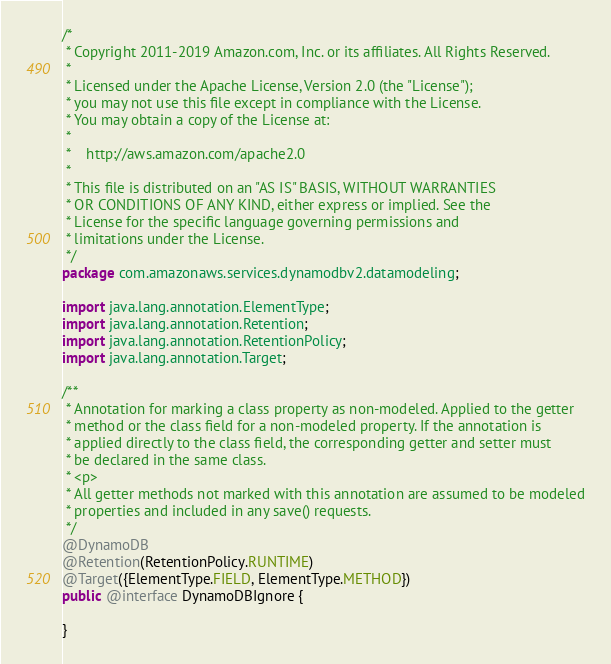<code> <loc_0><loc_0><loc_500><loc_500><_Java_>/*
 * Copyright 2011-2019 Amazon.com, Inc. or its affiliates. All Rights Reserved.
 *
 * Licensed under the Apache License, Version 2.0 (the "License");
 * you may not use this file except in compliance with the License.
 * You may obtain a copy of the License at:
 *
 *    http://aws.amazon.com/apache2.0
 *
 * This file is distributed on an "AS IS" BASIS, WITHOUT WARRANTIES
 * OR CONDITIONS OF ANY KIND, either express or implied. See the
 * License for the specific language governing permissions and
 * limitations under the License.
 */
package com.amazonaws.services.dynamodbv2.datamodeling;

import java.lang.annotation.ElementType;
import java.lang.annotation.Retention;
import java.lang.annotation.RetentionPolicy;
import java.lang.annotation.Target;

/**
 * Annotation for marking a class property as non-modeled. Applied to the getter
 * method or the class field for a non-modeled property. If the annotation is
 * applied directly to the class field, the corresponding getter and setter must
 * be declared in the same class.
 * <p>
 * All getter methods not marked with this annotation are assumed to be modeled
 * properties and included in any save() requests.
 */
@DynamoDB
@Retention(RetentionPolicy.RUNTIME)
@Target({ElementType.FIELD, ElementType.METHOD})
public @interface DynamoDBIgnore {

}
</code> 